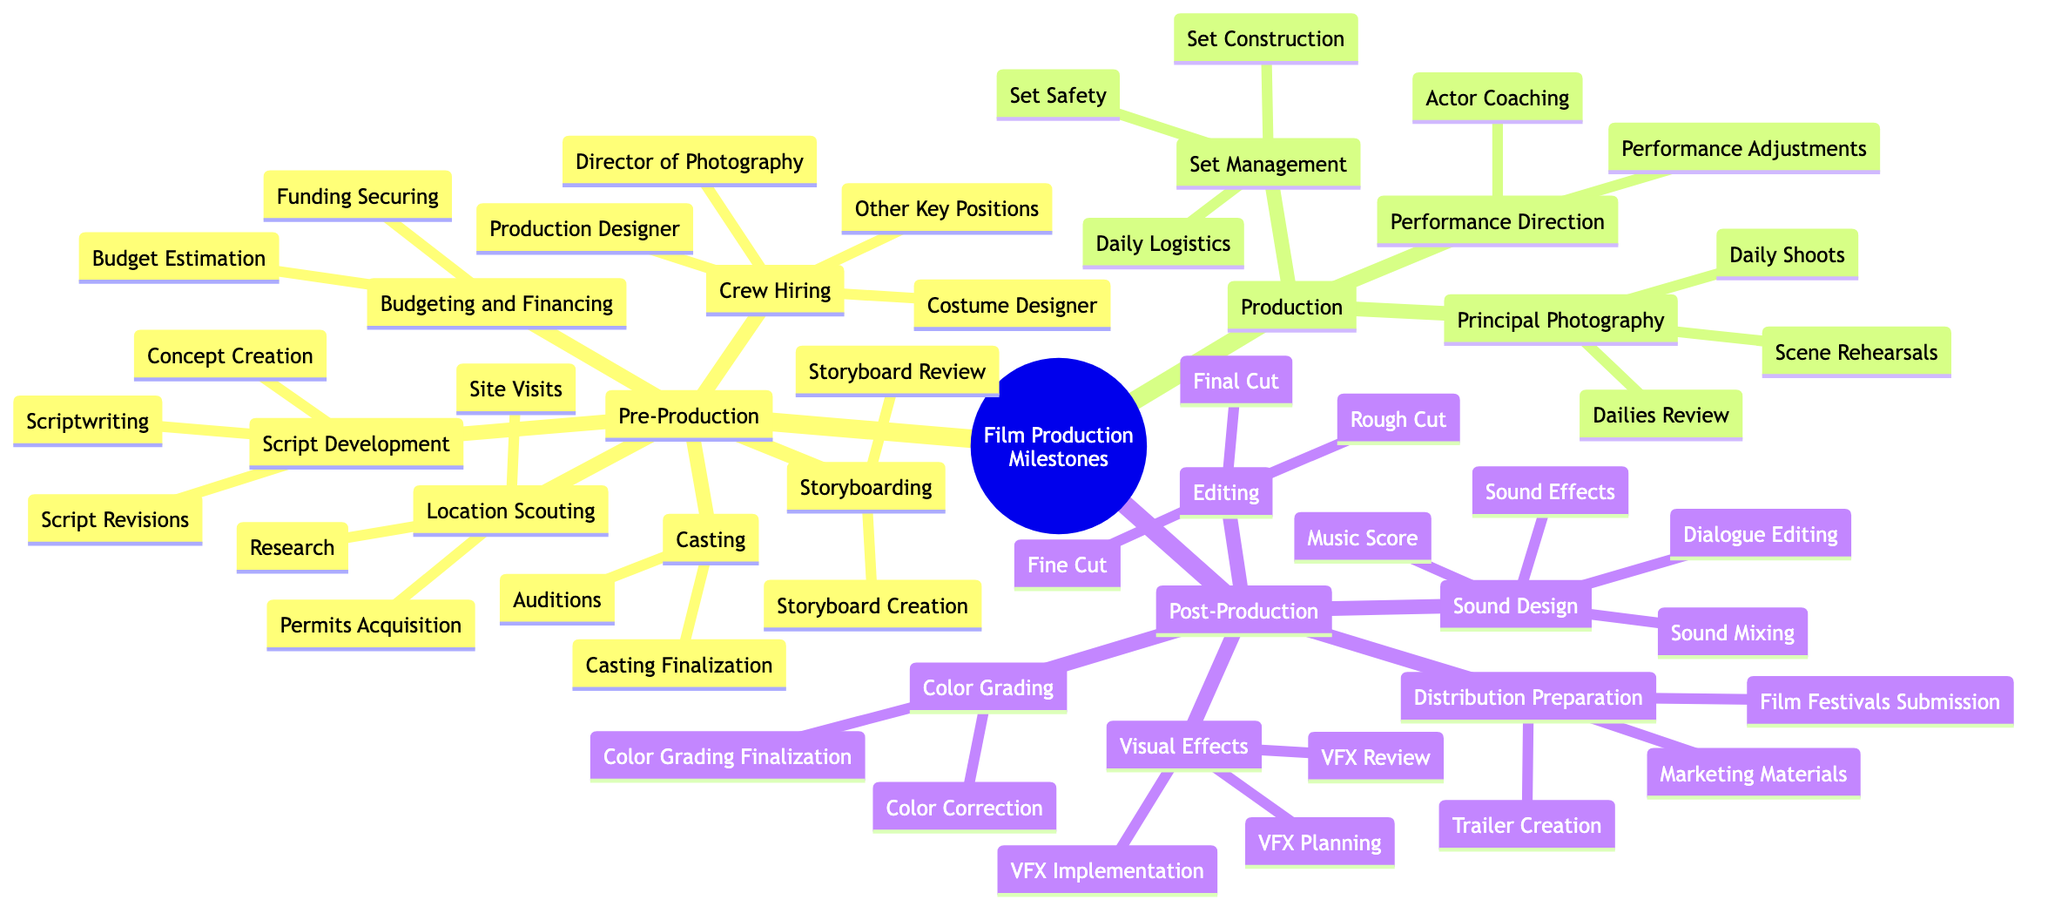What are the main phases of film production? The diagram has three main phases: Pre-Production, Production, and Post-Production, indicated as the top-level categories in the mind map.
Answer: Pre-Production, Production, Post-Production How many elements are there in the 'Casting' category? By locating the 'Casting' node in the diagram, I can see it contains two elements: Auditions and Casting Finalization. Thus, the count is 2.
Answer: 2 What is the first task listed under 'Budgeting and Financing'? In the 'Budgeting and Financing' category, the first task listed is 'Budget Estimation' as shown directly in the diagram.
Answer: Budget Estimation Which phase includes 'Scene Rehearsals'? 'Scene Rehearsals' is listed under the 'Principal Photography' category, which is a part of the 'Production' phase in the diagram.
Answer: Production How many key positions are mentioned under 'Crew Hiring'? Under 'Crew Hiring', there are four key positions mentioned: Director of Photography, Production Designer, Costume Designer, and Other Key Positions, thus the count is 4.
Answer: 4 What follows 'Fine Cut' in the editing process? In the 'Editing' category, 'Final Cut' follows 'Fine Cut' as part of the sequential process outlined in the mind map.
Answer: Final Cut What is the last element in the 'Sound Design' category? The last element in the 'Sound Design' category is 'Sound Mixing', which can be identified as the final item listed in that section of the diagram.
Answer: Sound Mixing Which element comes after 'VFX Planning'? According to the structure of the diagram in the 'Visual Effects' category, 'VFX Implementation' comes after 'VFX Planning'.
Answer: VFX Implementation What is the overall purpose of the 'Distribution Preparation' phase? The 'Distribution Preparation' phase includes tasks like Trailer Creation, Marketing Materials, and Film Festivals Submission, all aimed at preparing the film for release and audience engagement.
Answer: Distribution Preparation How many elements are listed under 'Color Grading'? The 'Color Grading' category contains two elements: Color Correction and Color Grading Finalization, making the total listed elements 2.
Answer: 2 